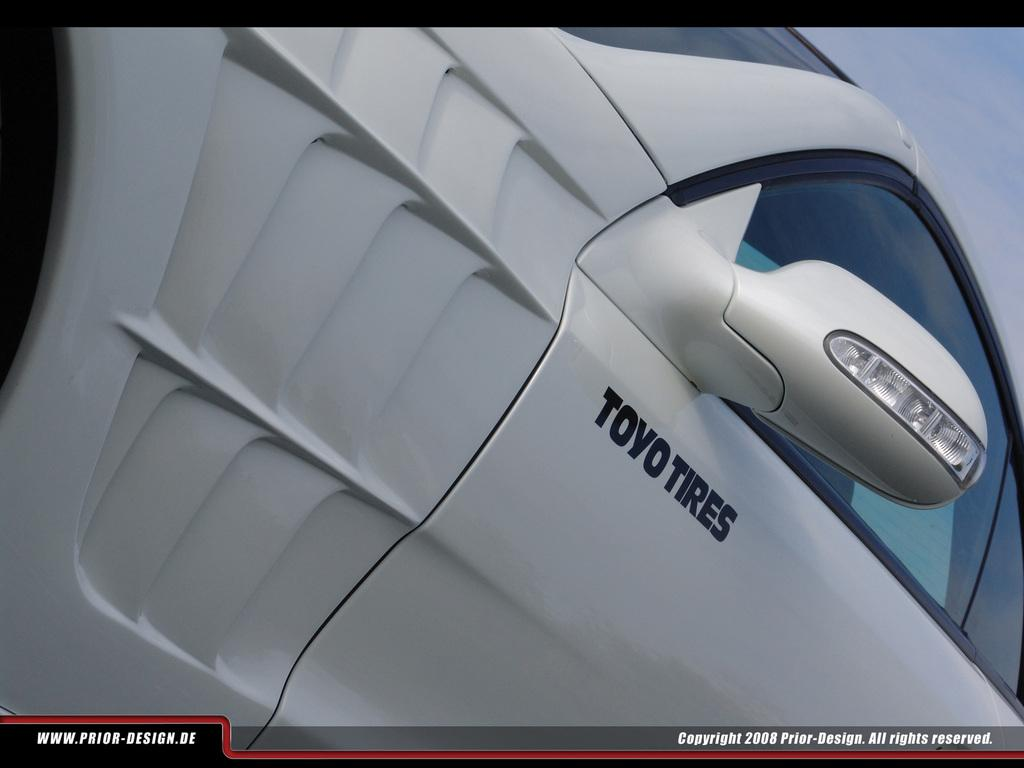What type of vehicle is in the image? There is a white car in the image. What historical event is depicted in the image involving a building and a bone? There is no building or bone present in the image; it only features a white car. 